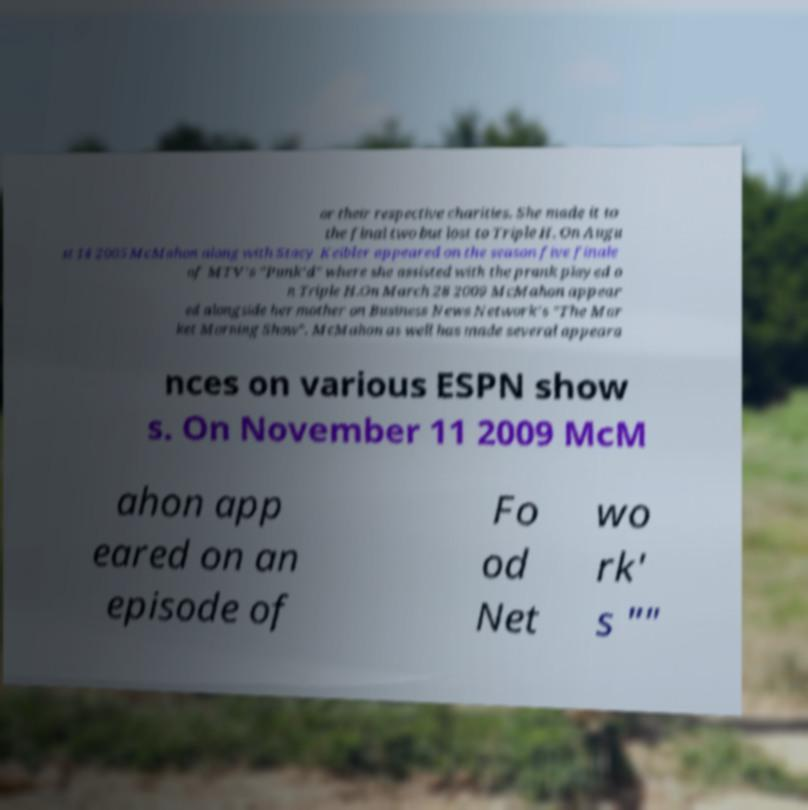Could you assist in decoding the text presented in this image and type it out clearly? or their respective charities. She made it to the final two but lost to Triple H. On Augu st 14 2005 McMahon along with Stacy Keibler appeared on the season five finale of MTV's "Punk'd" where she assisted with the prank played o n Triple H.On March 28 2009 McMahon appear ed alongside her mother on Business News Network's "The Mar ket Morning Show". McMahon as well has made several appeara nces on various ESPN show s. On November 11 2009 McM ahon app eared on an episode of Fo od Net wo rk' s "" 